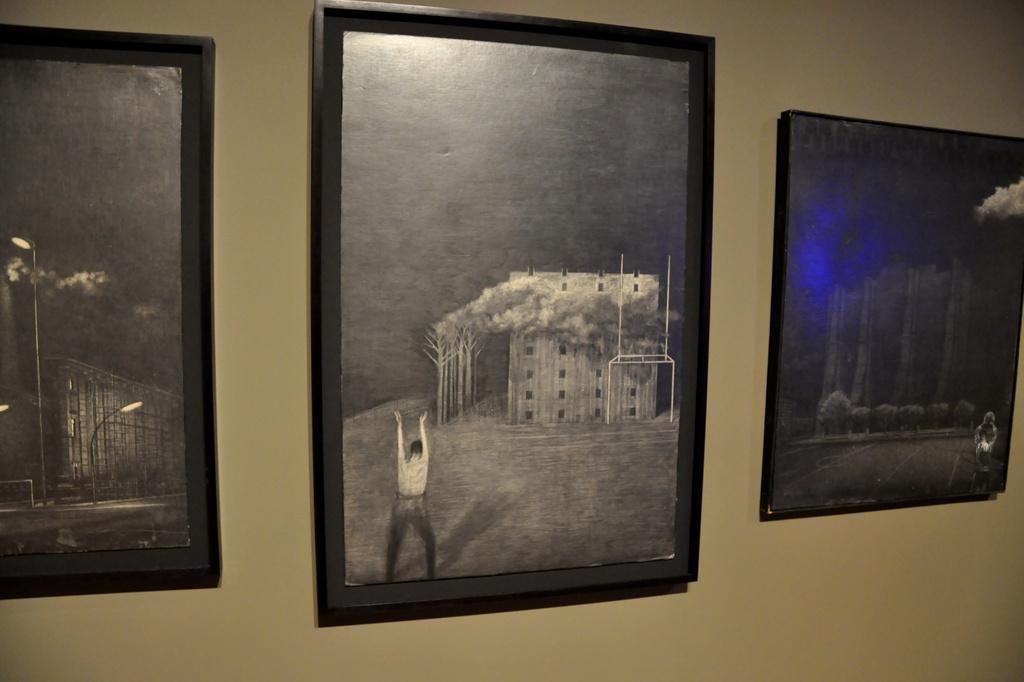Can you describe this image briefly? In this image we can some photo frames are attached to the wall. 